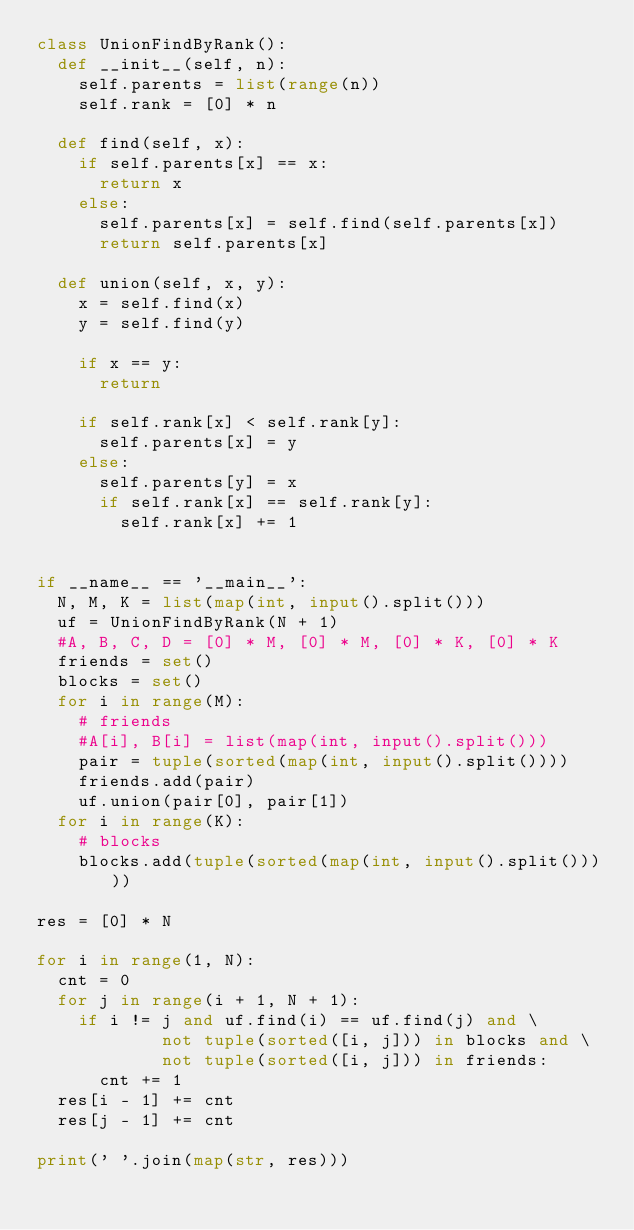Convert code to text. <code><loc_0><loc_0><loc_500><loc_500><_Python_>class UnionFindByRank():
  def __init__(self, n):
    self.parents = list(range(n))
    self.rank = [0] * n

  def find(self, x):
    if self.parents[x] == x:
      return x
    else:
      self.parents[x] = self.find(self.parents[x])
      return self.parents[x]

  def union(self, x, y):
    x = self.find(x)
    y = self.find(y)

    if x == y:
      return

    if self.rank[x] < self.rank[y]:
      self.parents[x] = y
    else:
      self.parents[y] = x
      if self.rank[x] == self.rank[y]:
        self.rank[x] += 1


if __name__ == '__main__':
  N, M, K = list(map(int, input().split()))
  uf = UnionFindByRank(N + 1)
  #A, B, C, D = [0] * M, [0] * M, [0] * K, [0] * K
  friends = set()
  blocks = set()
  for i in range(M):
    # friends
    #A[i], B[i] = list(map(int, input().split()))
    pair = tuple(sorted(map(int, input().split())))
    friends.add(pair)
    uf.union(pair[0], pair[1])
  for i in range(K):
    # blocks
    blocks.add(tuple(sorted(map(int, input().split()))))

res = [0] * N

for i in range(1, N):
  cnt = 0
  for j in range(i + 1, N + 1):
    if i != j and uf.find(i) == uf.find(j) and \
            not tuple(sorted([i, j])) in blocks and \
            not tuple(sorted([i, j])) in friends:
      cnt += 1
  res[i - 1] += cnt
  res[j - 1] += cnt

print(' '.join(map(str, res)))</code> 